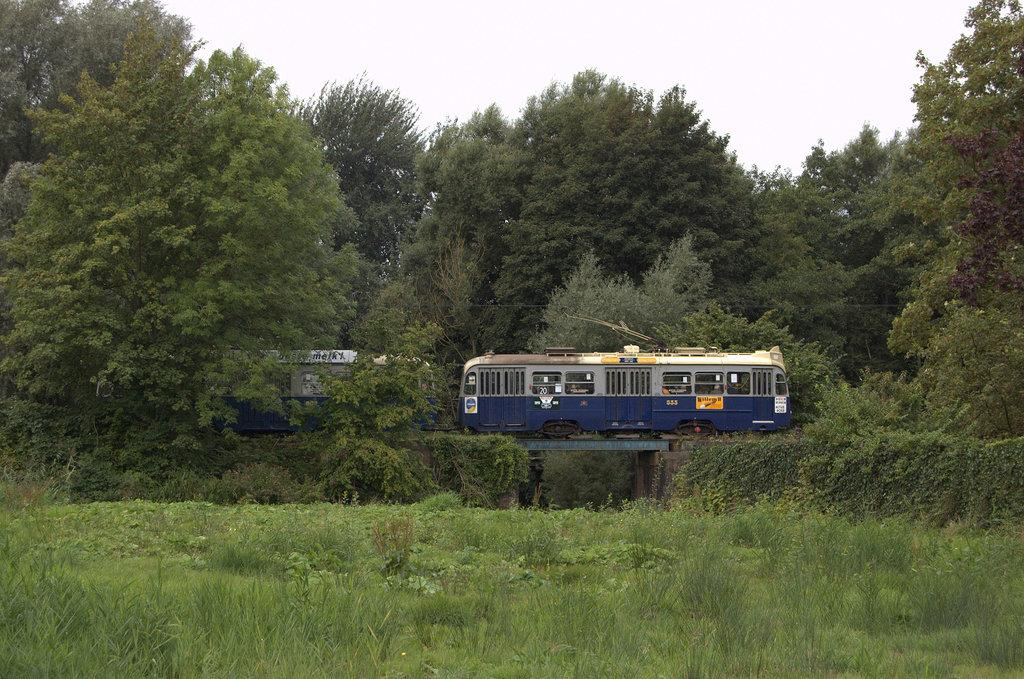What is the main subject of the image? The main subject of the image is a train. Where is the train located in the image? The train is on a railway track in the image. What type of vegetation can be seen in the image? There are trees, plants, and grass visible in the image. What is visible in the background of the image? The sky is visible in the background of the image. What part of the train is rubbing against the trees in the image? There is no indication in the image that any part of the train is rubbing against the trees. 